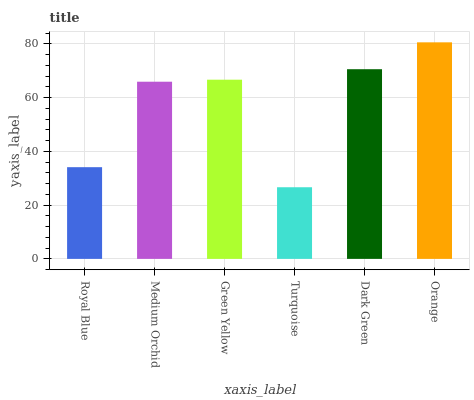Is Medium Orchid the minimum?
Answer yes or no. No. Is Medium Orchid the maximum?
Answer yes or no. No. Is Medium Orchid greater than Royal Blue?
Answer yes or no. Yes. Is Royal Blue less than Medium Orchid?
Answer yes or no. Yes. Is Royal Blue greater than Medium Orchid?
Answer yes or no. No. Is Medium Orchid less than Royal Blue?
Answer yes or no. No. Is Green Yellow the high median?
Answer yes or no. Yes. Is Medium Orchid the low median?
Answer yes or no. Yes. Is Turquoise the high median?
Answer yes or no. No. Is Green Yellow the low median?
Answer yes or no. No. 